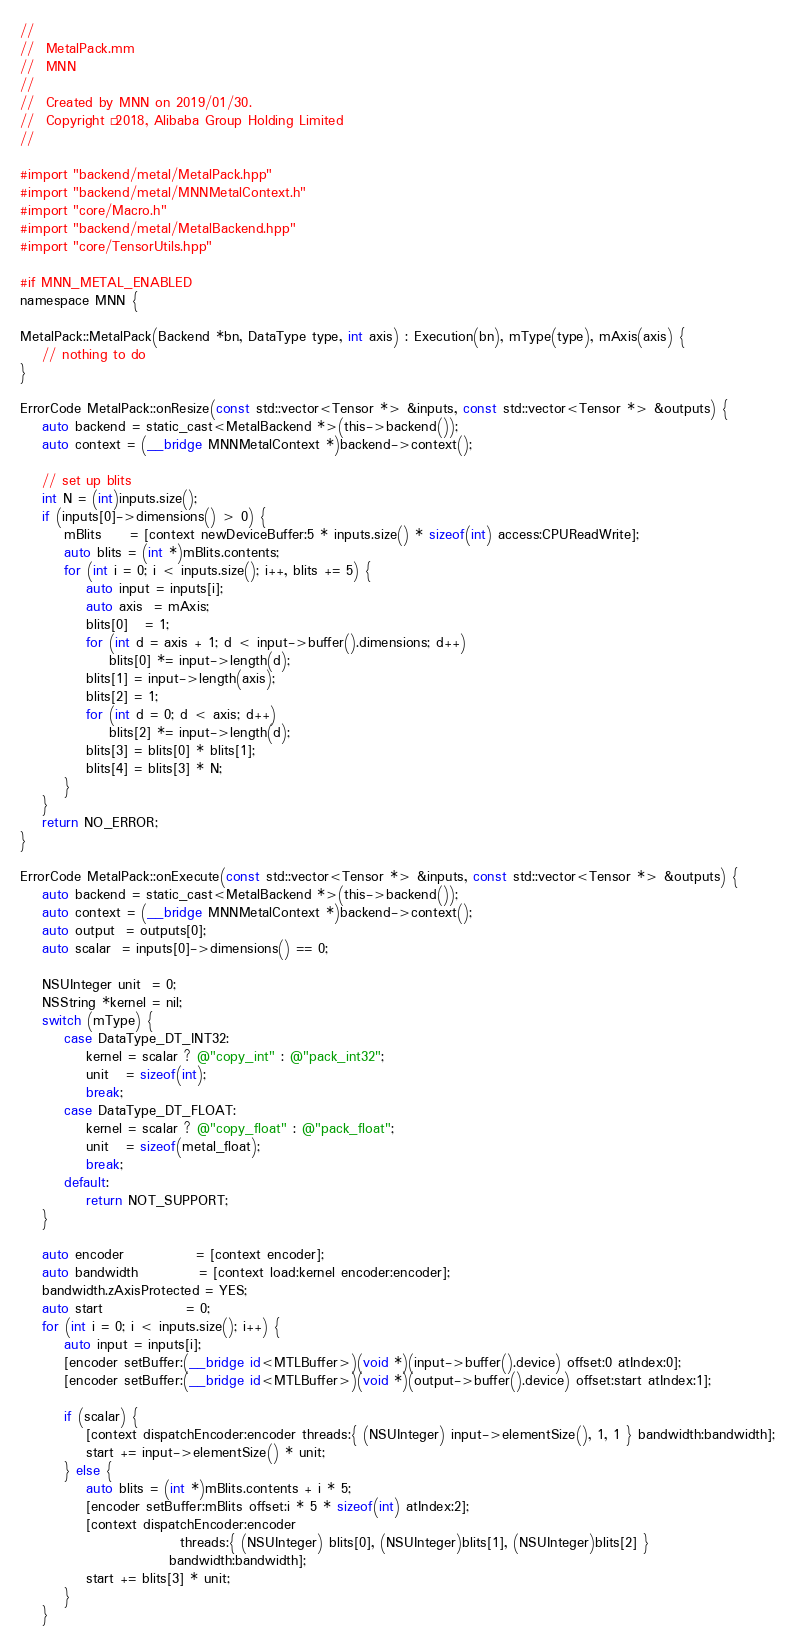<code> <loc_0><loc_0><loc_500><loc_500><_ObjectiveC_>//
//  MetalPack.mm
//  MNN
//
//  Created by MNN on 2019/01/30.
//  Copyright © 2018, Alibaba Group Holding Limited
//

#import "backend/metal/MetalPack.hpp"
#import "backend/metal/MNNMetalContext.h"
#import "core/Macro.h"
#import "backend/metal/MetalBackend.hpp"
#import "core/TensorUtils.hpp"

#if MNN_METAL_ENABLED
namespace MNN {

MetalPack::MetalPack(Backend *bn, DataType type, int axis) : Execution(bn), mType(type), mAxis(axis) {
    // nothing to do
}

ErrorCode MetalPack::onResize(const std::vector<Tensor *> &inputs, const std::vector<Tensor *> &outputs) {
    auto backend = static_cast<MetalBackend *>(this->backend());
    auto context = (__bridge MNNMetalContext *)backend->context();

    // set up blits
    int N = (int)inputs.size();
    if (inputs[0]->dimensions() > 0) {
        mBlits     = [context newDeviceBuffer:5 * inputs.size() * sizeof(int) access:CPUReadWrite];
        auto blits = (int *)mBlits.contents;
        for (int i = 0; i < inputs.size(); i++, blits += 5) {
            auto input = inputs[i];
            auto axis  = mAxis;
            blits[0]   = 1;
            for (int d = axis + 1; d < input->buffer().dimensions; d++)
                blits[0] *= input->length(d);
            blits[1] = input->length(axis);
            blits[2] = 1;
            for (int d = 0; d < axis; d++)
                blits[2] *= input->length(d);
            blits[3] = blits[0] * blits[1];
            blits[4] = blits[3] * N;
        }
    }
    return NO_ERROR;
}

ErrorCode MetalPack::onExecute(const std::vector<Tensor *> &inputs, const std::vector<Tensor *> &outputs) {
    auto backend = static_cast<MetalBackend *>(this->backend());
    auto context = (__bridge MNNMetalContext *)backend->context();
    auto output  = outputs[0];
    auto scalar  = inputs[0]->dimensions() == 0;

    NSUInteger unit  = 0;
    NSString *kernel = nil;
    switch (mType) {
        case DataType_DT_INT32:
            kernel = scalar ? @"copy_int" : @"pack_int32";
            unit   = sizeof(int);
            break;
        case DataType_DT_FLOAT:
            kernel = scalar ? @"copy_float" : @"pack_float";
            unit   = sizeof(metal_float);
            break;
        default:
            return NOT_SUPPORT;
    }

    auto encoder             = [context encoder];
    auto bandwidth           = [context load:kernel encoder:encoder];
    bandwidth.zAxisProtected = YES;
    auto start               = 0;
    for (int i = 0; i < inputs.size(); i++) {
        auto input = inputs[i];
        [encoder setBuffer:(__bridge id<MTLBuffer>)(void *)(input->buffer().device) offset:0 atIndex:0];
        [encoder setBuffer:(__bridge id<MTLBuffer>)(void *)(output->buffer().device) offset:start atIndex:1];

        if (scalar) {
            [context dispatchEncoder:encoder threads:{ (NSUInteger) input->elementSize(), 1, 1 } bandwidth:bandwidth];
            start += input->elementSize() * unit;
        } else {
            auto blits = (int *)mBlits.contents + i * 5;
            [encoder setBuffer:mBlits offset:i * 5 * sizeof(int) atIndex:2];
            [context dispatchEncoder:encoder
                             threads:{ (NSUInteger) blits[0], (NSUInteger)blits[1], (NSUInteger)blits[2] }
                           bandwidth:bandwidth];
            start += blits[3] * unit;
        }
    }</code> 